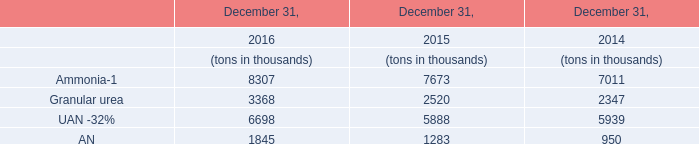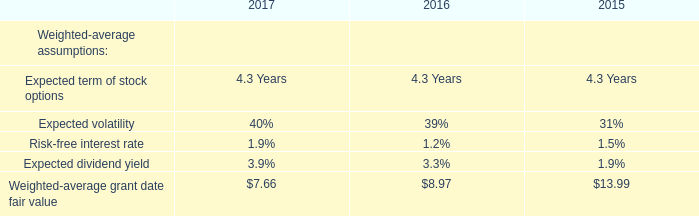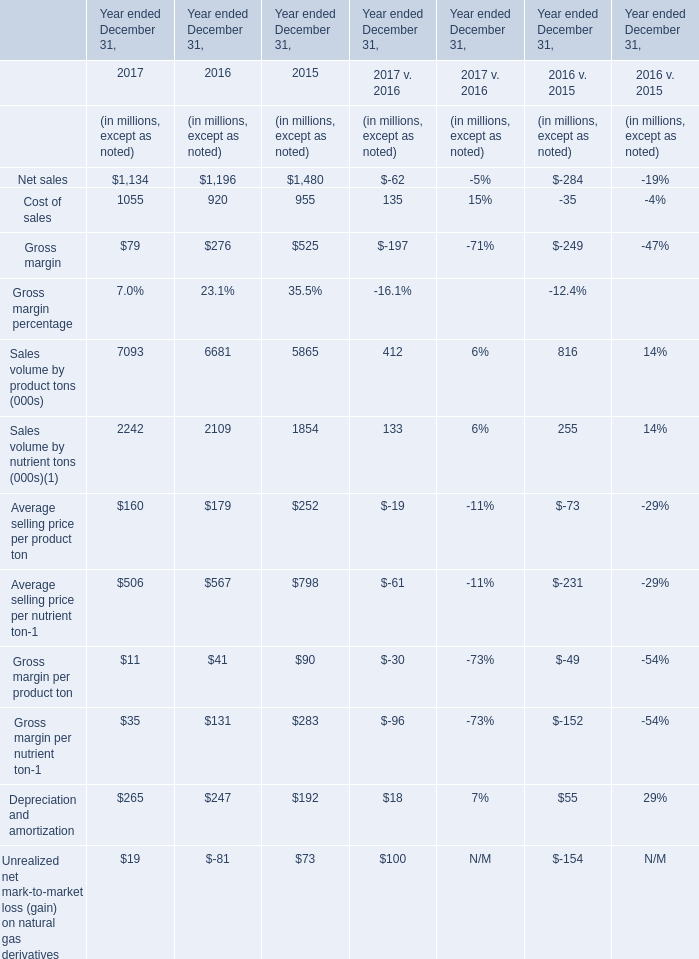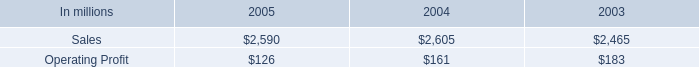What is the total value of Net sales, Cost of sales, Gross margin and Depreciation and amortization in in 2017? (in dollars in millions) 
Computations: (((1134 + 1055) + 79) + 265)
Answer: 2533.0. 